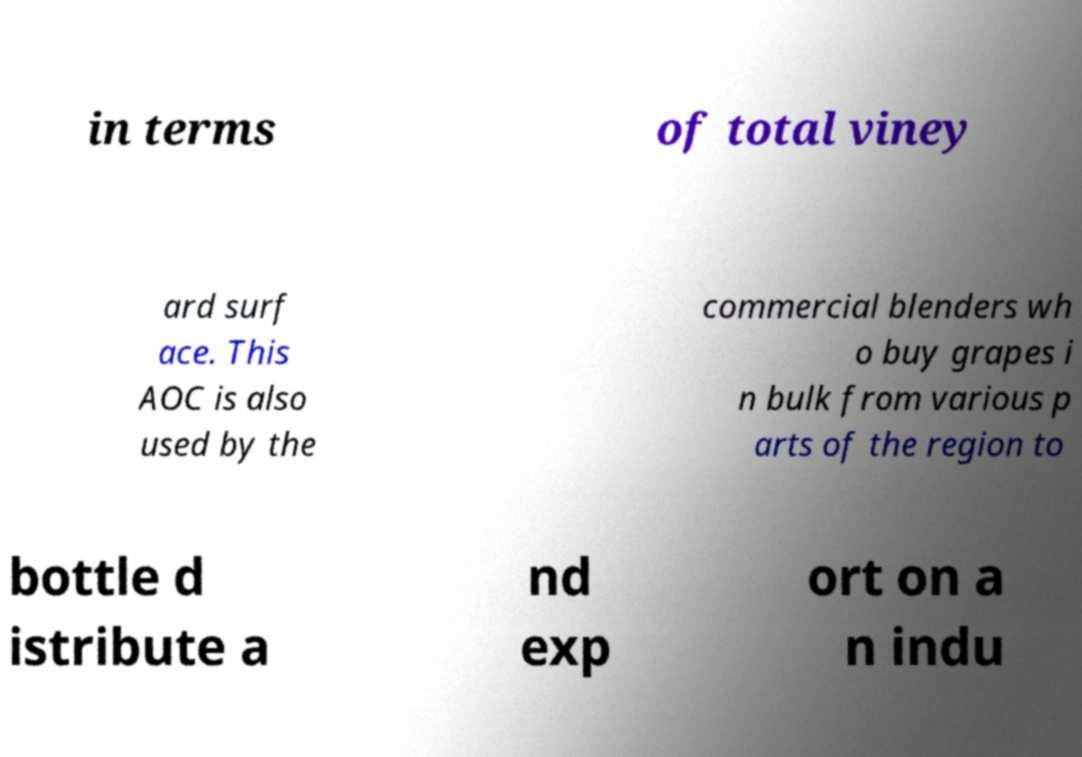Could you extract and type out the text from this image? in terms of total viney ard surf ace. This AOC is also used by the commercial blenders wh o buy grapes i n bulk from various p arts of the region to bottle d istribute a nd exp ort on a n indu 